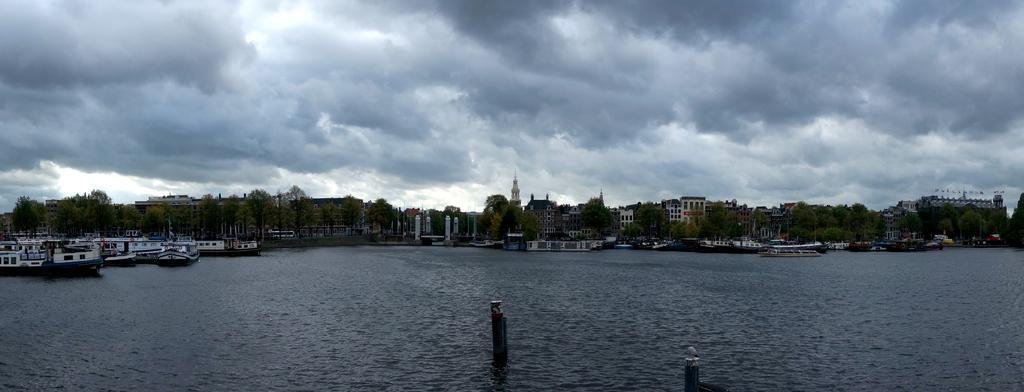Can you describe this image briefly? This is the picture of a city. In this image there are buildings and trees and there are boats on the water. At the top there is sky and there are clouds. At the bottom there is water and there it looks like pipes in the water. 